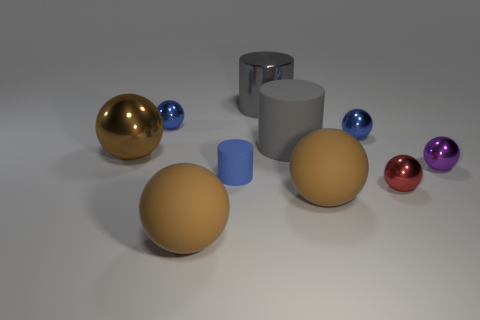Is the color of the large metal cylinder the same as the large rubber cylinder?
Your answer should be compact. Yes. The large brown object that is in front of the brown matte thing right of the big gray object that is right of the big metal cylinder is made of what material?
Provide a succinct answer. Rubber. There is a metal cylinder; how many big metal cylinders are in front of it?
Your response must be concise. 0. Is the shape of the blue rubber thing the same as the blue metal thing that is to the right of the tiny cylinder?
Your answer should be compact. No. Are there any big gray shiny things of the same shape as the blue rubber thing?
Ensure brevity in your answer.  Yes. The large brown matte object in front of the brown sphere that is on the right side of the metal cylinder is what shape?
Make the answer very short. Sphere. There is a small blue object that is to the right of the blue rubber object; what is its shape?
Make the answer very short. Sphere. There is a small shiny ball that is to the left of the tiny rubber cylinder; is its color the same as the rubber cylinder left of the large shiny cylinder?
Your answer should be very brief. Yes. What number of small things are on the left side of the small red sphere and in front of the brown shiny sphere?
Your answer should be compact. 1. What is the size of the gray thing that is made of the same material as the tiny purple sphere?
Keep it short and to the point. Large. 